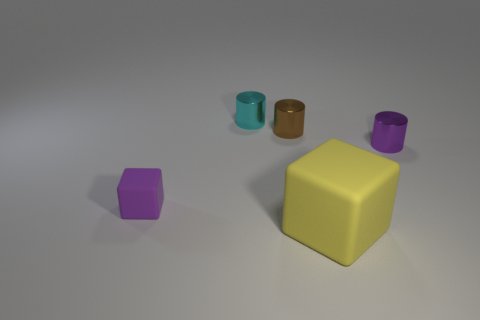Add 5 rubber cylinders. How many objects exist? 10 Subtract all cubes. How many objects are left? 3 Add 1 tiny objects. How many tiny objects are left? 5 Add 5 brown shiny cylinders. How many brown shiny cylinders exist? 6 Subtract 0 red cubes. How many objects are left? 5 Subtract all tiny cyan shiny cylinders. Subtract all small green matte things. How many objects are left? 4 